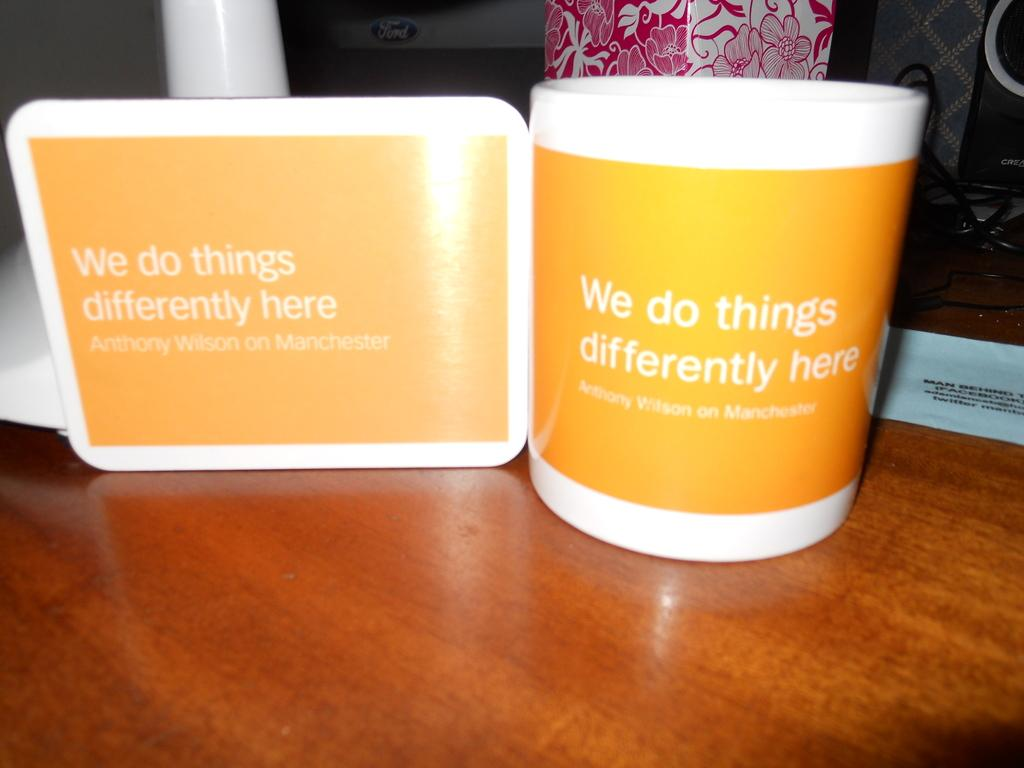<image>
Render a clear and concise summary of the photo. A cup with a quote by Anthony Wilson is orange and white. 